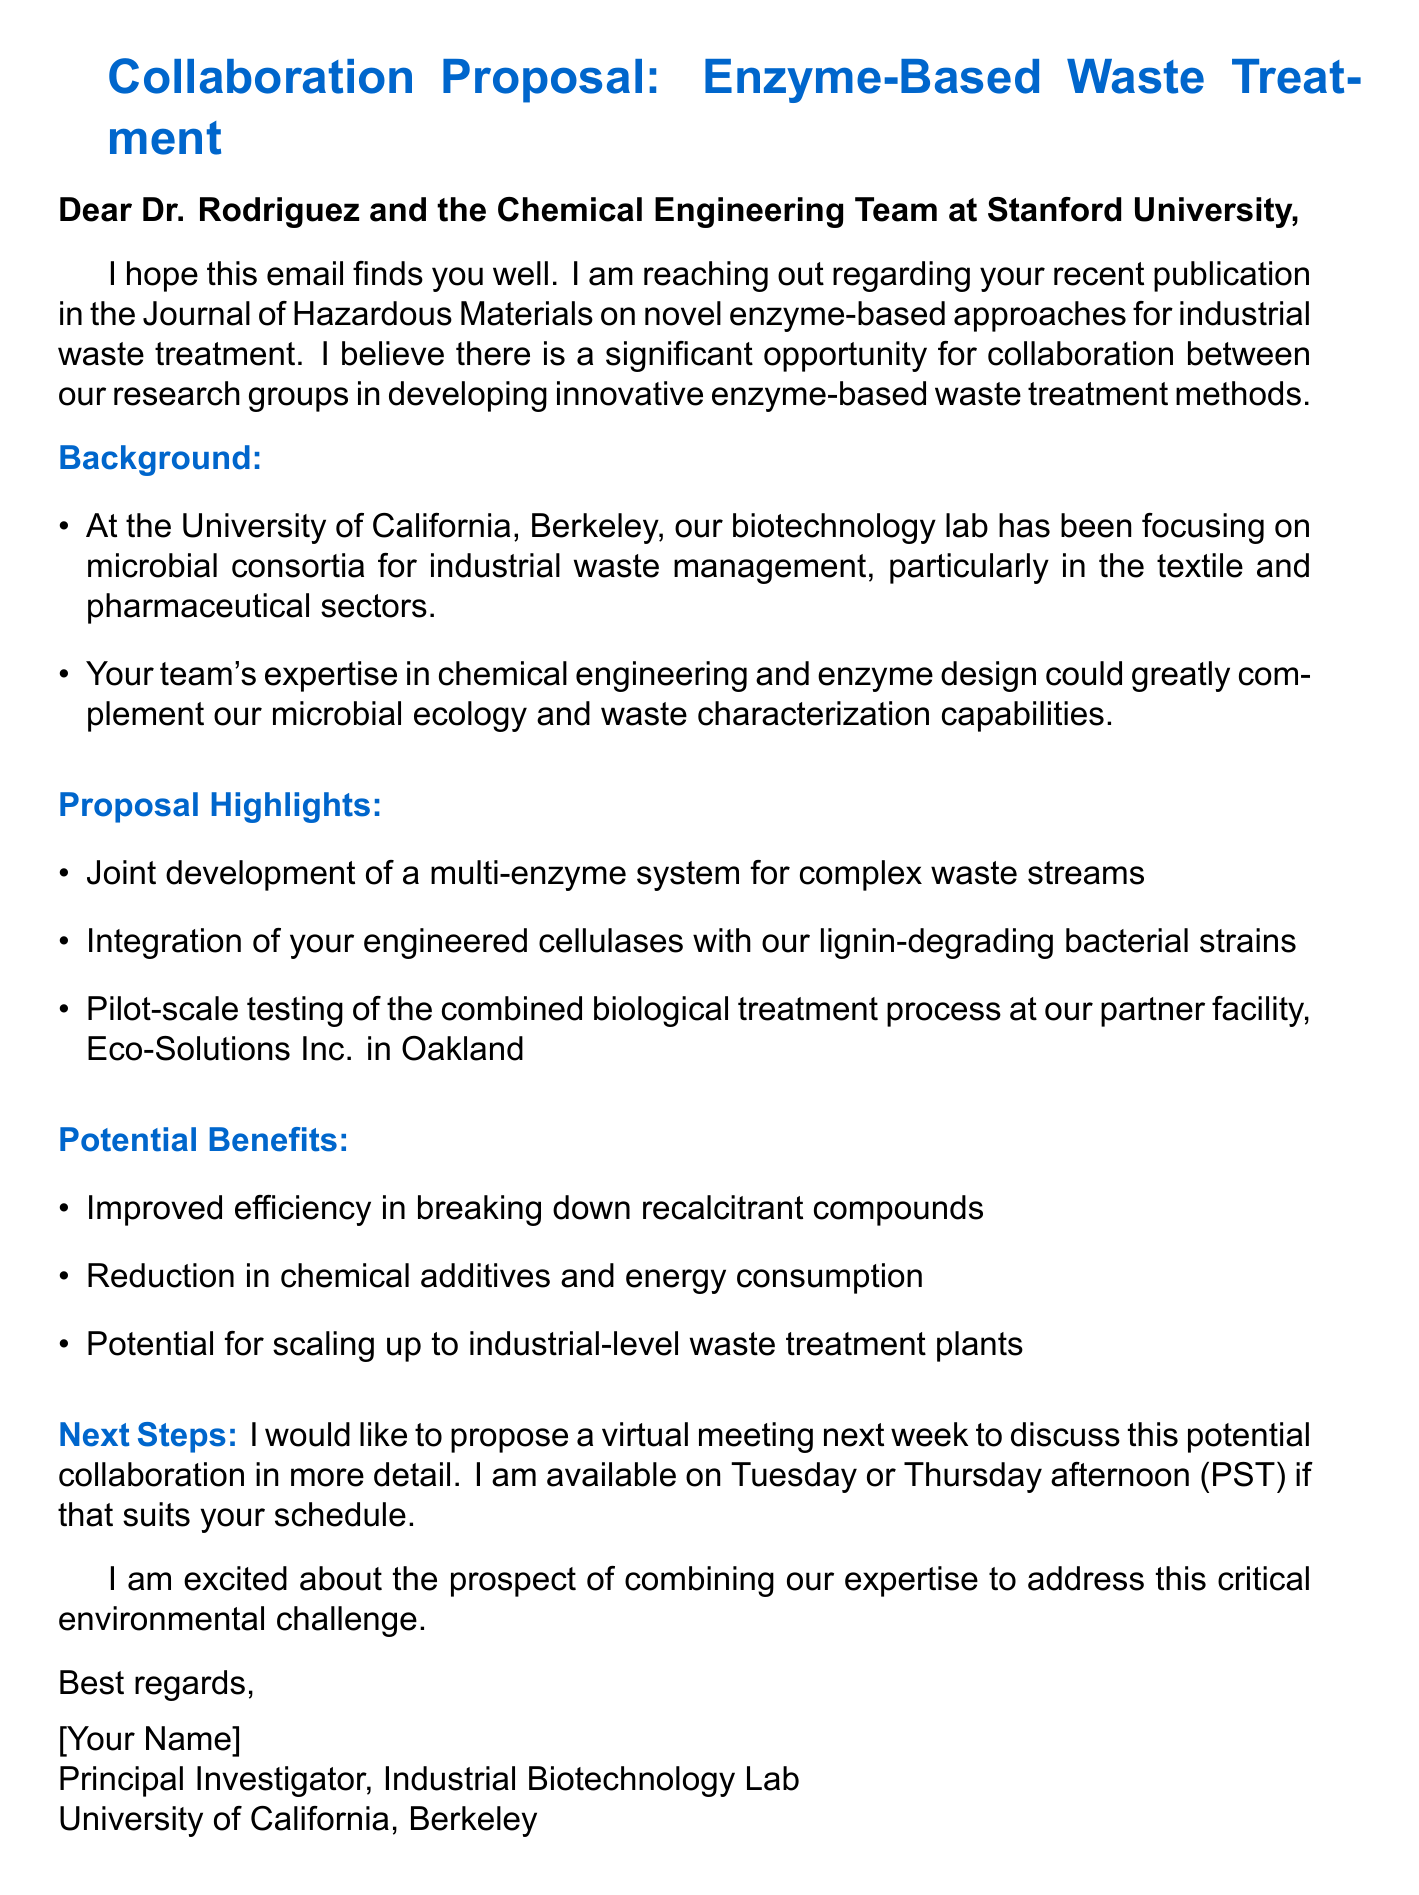What is the name of the publication mentioned in the email? The publication referenced is titled "Journal of Hazardous Materials."
Answer: Journal of Hazardous Materials Which university is the sender associated with? The sender is affiliated with the University of California, Berkeley.
Answer: University of California, Berkeley What are the suggested days for the meeting? The sender suggests meeting on Tuesday or Thursday afternoon.
Answer: Tuesday or Thursday afternoon What is the main focus of the sender's current research? The sender's lab focuses on microbial consortia for industrial waste management.
Answer: Microbial consortia for industrial waste management What is one potential benefit of the proposed collaboration? One potential benefit mentioned is the improved efficiency in breaking down recalcitrant compounds.
Answer: Improved efficiency in breaking down recalcitrant compounds What type of system is proposed for development? The proposal involves the joint development of a multi-enzyme system.
Answer: Multi-enzyme system What facility will pilot-scale testing occur at? The pilot-scale testing will be conducted at Eco-Solutions Inc. in Oakland.
Answer: Eco-Solutions Inc. in Oakland What is the tone of the closing statement? The closing statement displays excitement about the collaboration prospects.
Answer: Excited 